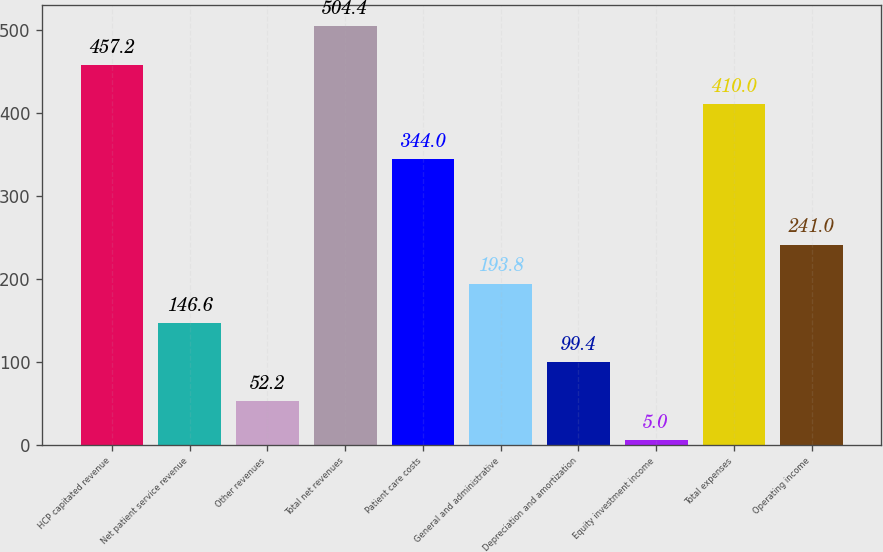Convert chart. <chart><loc_0><loc_0><loc_500><loc_500><bar_chart><fcel>HCP capitated revenue<fcel>Net patient service revenue<fcel>Other revenues<fcel>Total net revenues<fcel>Patient care costs<fcel>General and administrative<fcel>Depreciation and amortization<fcel>Equity investment income<fcel>Total expenses<fcel>Operating income<nl><fcel>457.2<fcel>146.6<fcel>52.2<fcel>504.4<fcel>344<fcel>193.8<fcel>99.4<fcel>5<fcel>410<fcel>241<nl></chart> 